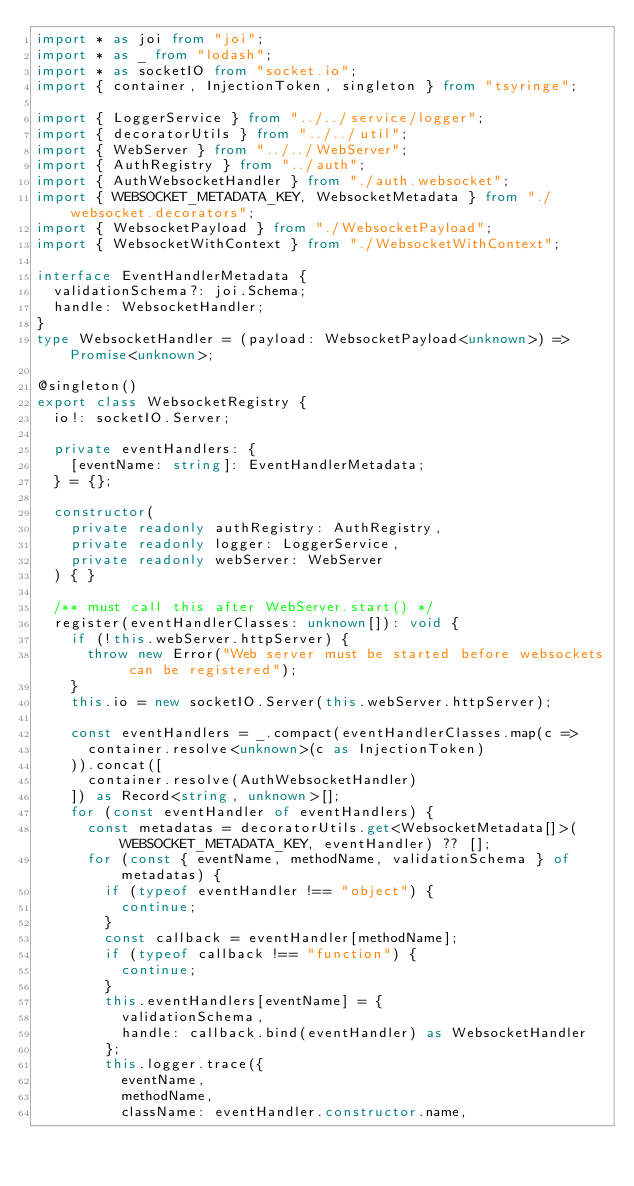<code> <loc_0><loc_0><loc_500><loc_500><_TypeScript_>import * as joi from "joi";
import * as _ from "lodash";
import * as socketIO from "socket.io";
import { container, InjectionToken, singleton } from "tsyringe";

import { LoggerService } from "../../service/logger";
import { decoratorUtils } from "../../util";
import { WebServer } from "../../WebServer";
import { AuthRegistry } from "../auth";
import { AuthWebsocketHandler } from "./auth.websocket";
import { WEBSOCKET_METADATA_KEY, WebsocketMetadata } from "./websocket.decorators";
import { WebsocketPayload } from "./WebsocketPayload";
import { WebsocketWithContext } from "./WebsocketWithContext";

interface EventHandlerMetadata {
  validationSchema?: joi.Schema;
  handle: WebsocketHandler;
}
type WebsocketHandler = (payload: WebsocketPayload<unknown>) => Promise<unknown>;

@singleton()
export class WebsocketRegistry {
  io!: socketIO.Server;

  private eventHandlers: {
    [eventName: string]: EventHandlerMetadata;
  } = {};

  constructor(
    private readonly authRegistry: AuthRegistry,
    private readonly logger: LoggerService,
    private readonly webServer: WebServer
  ) { }

  /** must call this after WebServer.start() */
  register(eventHandlerClasses: unknown[]): void {
    if (!this.webServer.httpServer) {
      throw new Error("Web server must be started before websockets can be registered");
    }
    this.io = new socketIO.Server(this.webServer.httpServer);

    const eventHandlers = _.compact(eventHandlerClasses.map(c =>
      container.resolve<unknown>(c as InjectionToken)
    )).concat([
      container.resolve(AuthWebsocketHandler)
    ]) as Record<string, unknown>[];
    for (const eventHandler of eventHandlers) {
      const metadatas = decoratorUtils.get<WebsocketMetadata[]>(WEBSOCKET_METADATA_KEY, eventHandler) ?? [];
      for (const { eventName, methodName, validationSchema } of metadatas) {
        if (typeof eventHandler !== "object") {
          continue;
        }
        const callback = eventHandler[methodName];
        if (typeof callback !== "function") {
          continue;
        }
        this.eventHandlers[eventName] = {
          validationSchema,
          handle: callback.bind(eventHandler) as WebsocketHandler
        };
        this.logger.trace({
          eventName,
          methodName,
          className: eventHandler.constructor.name,</code> 